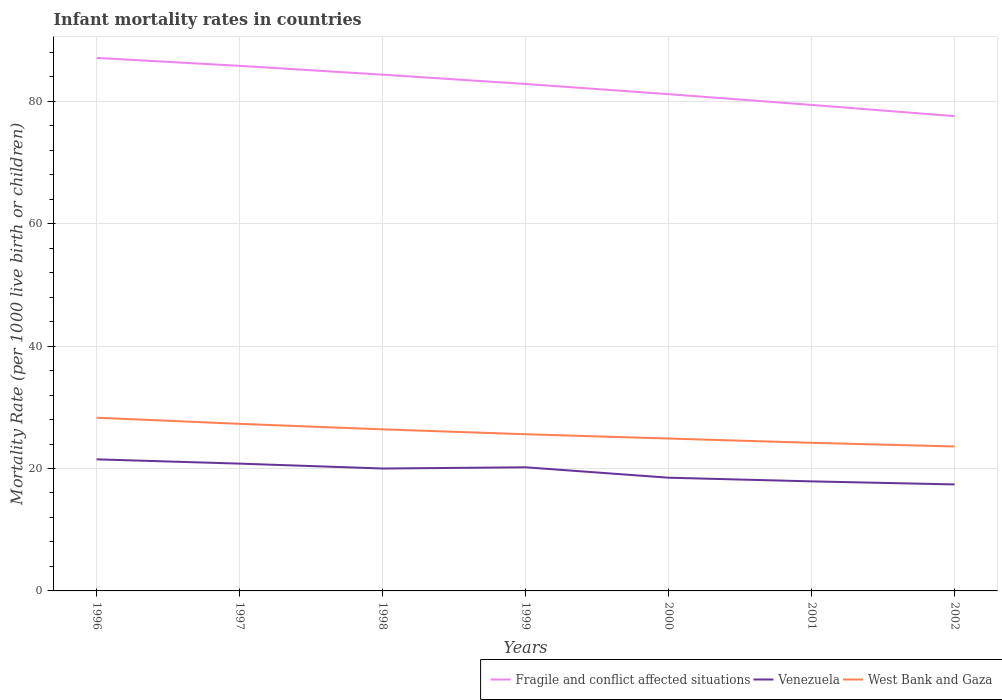Is the number of lines equal to the number of legend labels?
Provide a succinct answer. Yes. Across all years, what is the maximum infant mortality rate in Venezuela?
Keep it short and to the point. 17.4. In which year was the infant mortality rate in Venezuela maximum?
Keep it short and to the point. 2002. What is the total infant mortality rate in Venezuela in the graph?
Offer a terse response. 3.6. What is the difference between the highest and the second highest infant mortality rate in Fragile and conflict affected situations?
Provide a succinct answer. 9.52. Is the infant mortality rate in West Bank and Gaza strictly greater than the infant mortality rate in Venezuela over the years?
Ensure brevity in your answer.  No. What is the difference between two consecutive major ticks on the Y-axis?
Give a very brief answer. 20. Does the graph contain any zero values?
Offer a very short reply. No. Does the graph contain grids?
Your response must be concise. Yes. Where does the legend appear in the graph?
Give a very brief answer. Bottom right. How are the legend labels stacked?
Keep it short and to the point. Horizontal. What is the title of the graph?
Give a very brief answer. Infant mortality rates in countries. What is the label or title of the X-axis?
Offer a very short reply. Years. What is the label or title of the Y-axis?
Give a very brief answer. Mortality Rate (per 1000 live birth or children). What is the Mortality Rate (per 1000 live birth or children) of Fragile and conflict affected situations in 1996?
Ensure brevity in your answer.  87.09. What is the Mortality Rate (per 1000 live birth or children) in West Bank and Gaza in 1996?
Your answer should be very brief. 28.3. What is the Mortality Rate (per 1000 live birth or children) in Fragile and conflict affected situations in 1997?
Provide a succinct answer. 85.79. What is the Mortality Rate (per 1000 live birth or children) in Venezuela in 1997?
Give a very brief answer. 20.8. What is the Mortality Rate (per 1000 live birth or children) in West Bank and Gaza in 1997?
Your answer should be compact. 27.3. What is the Mortality Rate (per 1000 live birth or children) in Fragile and conflict affected situations in 1998?
Ensure brevity in your answer.  84.35. What is the Mortality Rate (per 1000 live birth or children) in West Bank and Gaza in 1998?
Provide a short and direct response. 26.4. What is the Mortality Rate (per 1000 live birth or children) of Fragile and conflict affected situations in 1999?
Give a very brief answer. 82.83. What is the Mortality Rate (per 1000 live birth or children) of Venezuela in 1999?
Make the answer very short. 20.2. What is the Mortality Rate (per 1000 live birth or children) of West Bank and Gaza in 1999?
Provide a succinct answer. 25.6. What is the Mortality Rate (per 1000 live birth or children) of Fragile and conflict affected situations in 2000?
Make the answer very short. 81.17. What is the Mortality Rate (per 1000 live birth or children) in West Bank and Gaza in 2000?
Make the answer very short. 24.9. What is the Mortality Rate (per 1000 live birth or children) of Fragile and conflict affected situations in 2001?
Give a very brief answer. 79.41. What is the Mortality Rate (per 1000 live birth or children) of West Bank and Gaza in 2001?
Make the answer very short. 24.2. What is the Mortality Rate (per 1000 live birth or children) in Fragile and conflict affected situations in 2002?
Offer a terse response. 77.58. What is the Mortality Rate (per 1000 live birth or children) in West Bank and Gaza in 2002?
Give a very brief answer. 23.6. Across all years, what is the maximum Mortality Rate (per 1000 live birth or children) in Fragile and conflict affected situations?
Provide a short and direct response. 87.09. Across all years, what is the maximum Mortality Rate (per 1000 live birth or children) in Venezuela?
Provide a short and direct response. 21.5. Across all years, what is the maximum Mortality Rate (per 1000 live birth or children) in West Bank and Gaza?
Keep it short and to the point. 28.3. Across all years, what is the minimum Mortality Rate (per 1000 live birth or children) of Fragile and conflict affected situations?
Your answer should be compact. 77.58. Across all years, what is the minimum Mortality Rate (per 1000 live birth or children) in Venezuela?
Provide a succinct answer. 17.4. Across all years, what is the minimum Mortality Rate (per 1000 live birth or children) in West Bank and Gaza?
Your answer should be compact. 23.6. What is the total Mortality Rate (per 1000 live birth or children) in Fragile and conflict affected situations in the graph?
Make the answer very short. 578.23. What is the total Mortality Rate (per 1000 live birth or children) of Venezuela in the graph?
Provide a succinct answer. 136.3. What is the total Mortality Rate (per 1000 live birth or children) of West Bank and Gaza in the graph?
Give a very brief answer. 180.3. What is the difference between the Mortality Rate (per 1000 live birth or children) of Fragile and conflict affected situations in 1996 and that in 1997?
Offer a terse response. 1.3. What is the difference between the Mortality Rate (per 1000 live birth or children) of Fragile and conflict affected situations in 1996 and that in 1998?
Make the answer very short. 2.74. What is the difference between the Mortality Rate (per 1000 live birth or children) in Venezuela in 1996 and that in 1998?
Ensure brevity in your answer.  1.5. What is the difference between the Mortality Rate (per 1000 live birth or children) in Fragile and conflict affected situations in 1996 and that in 1999?
Ensure brevity in your answer.  4.26. What is the difference between the Mortality Rate (per 1000 live birth or children) of Fragile and conflict affected situations in 1996 and that in 2000?
Provide a succinct answer. 5.93. What is the difference between the Mortality Rate (per 1000 live birth or children) in Venezuela in 1996 and that in 2000?
Make the answer very short. 3. What is the difference between the Mortality Rate (per 1000 live birth or children) of Fragile and conflict affected situations in 1996 and that in 2001?
Provide a short and direct response. 7.68. What is the difference between the Mortality Rate (per 1000 live birth or children) in Fragile and conflict affected situations in 1996 and that in 2002?
Offer a very short reply. 9.52. What is the difference between the Mortality Rate (per 1000 live birth or children) of Venezuela in 1996 and that in 2002?
Offer a very short reply. 4.1. What is the difference between the Mortality Rate (per 1000 live birth or children) of Fragile and conflict affected situations in 1997 and that in 1998?
Offer a terse response. 1.44. What is the difference between the Mortality Rate (per 1000 live birth or children) of Fragile and conflict affected situations in 1997 and that in 1999?
Your answer should be very brief. 2.96. What is the difference between the Mortality Rate (per 1000 live birth or children) in Venezuela in 1997 and that in 1999?
Your response must be concise. 0.6. What is the difference between the Mortality Rate (per 1000 live birth or children) in Fragile and conflict affected situations in 1997 and that in 2000?
Give a very brief answer. 4.63. What is the difference between the Mortality Rate (per 1000 live birth or children) in Venezuela in 1997 and that in 2000?
Provide a succinct answer. 2.3. What is the difference between the Mortality Rate (per 1000 live birth or children) in Fragile and conflict affected situations in 1997 and that in 2001?
Your answer should be compact. 6.38. What is the difference between the Mortality Rate (per 1000 live birth or children) in Venezuela in 1997 and that in 2001?
Give a very brief answer. 2.9. What is the difference between the Mortality Rate (per 1000 live birth or children) of Fragile and conflict affected situations in 1997 and that in 2002?
Offer a terse response. 8.22. What is the difference between the Mortality Rate (per 1000 live birth or children) of West Bank and Gaza in 1997 and that in 2002?
Offer a terse response. 3.7. What is the difference between the Mortality Rate (per 1000 live birth or children) of Fragile and conflict affected situations in 1998 and that in 1999?
Your answer should be very brief. 1.52. What is the difference between the Mortality Rate (per 1000 live birth or children) of Fragile and conflict affected situations in 1998 and that in 2000?
Offer a terse response. 3.19. What is the difference between the Mortality Rate (per 1000 live birth or children) of Fragile and conflict affected situations in 1998 and that in 2001?
Give a very brief answer. 4.94. What is the difference between the Mortality Rate (per 1000 live birth or children) of West Bank and Gaza in 1998 and that in 2001?
Offer a very short reply. 2.2. What is the difference between the Mortality Rate (per 1000 live birth or children) in Fragile and conflict affected situations in 1998 and that in 2002?
Provide a short and direct response. 6.78. What is the difference between the Mortality Rate (per 1000 live birth or children) of West Bank and Gaza in 1998 and that in 2002?
Provide a succinct answer. 2.8. What is the difference between the Mortality Rate (per 1000 live birth or children) in Fragile and conflict affected situations in 1999 and that in 2000?
Your answer should be compact. 1.67. What is the difference between the Mortality Rate (per 1000 live birth or children) in Venezuela in 1999 and that in 2000?
Ensure brevity in your answer.  1.7. What is the difference between the Mortality Rate (per 1000 live birth or children) in West Bank and Gaza in 1999 and that in 2000?
Make the answer very short. 0.7. What is the difference between the Mortality Rate (per 1000 live birth or children) of Fragile and conflict affected situations in 1999 and that in 2001?
Offer a terse response. 3.42. What is the difference between the Mortality Rate (per 1000 live birth or children) of West Bank and Gaza in 1999 and that in 2001?
Make the answer very short. 1.4. What is the difference between the Mortality Rate (per 1000 live birth or children) of Fragile and conflict affected situations in 1999 and that in 2002?
Your answer should be compact. 5.26. What is the difference between the Mortality Rate (per 1000 live birth or children) in West Bank and Gaza in 1999 and that in 2002?
Keep it short and to the point. 2. What is the difference between the Mortality Rate (per 1000 live birth or children) of Fragile and conflict affected situations in 2000 and that in 2001?
Provide a succinct answer. 1.76. What is the difference between the Mortality Rate (per 1000 live birth or children) in Fragile and conflict affected situations in 2000 and that in 2002?
Offer a terse response. 3.59. What is the difference between the Mortality Rate (per 1000 live birth or children) in Venezuela in 2000 and that in 2002?
Ensure brevity in your answer.  1.1. What is the difference between the Mortality Rate (per 1000 live birth or children) of West Bank and Gaza in 2000 and that in 2002?
Make the answer very short. 1.3. What is the difference between the Mortality Rate (per 1000 live birth or children) in Fragile and conflict affected situations in 2001 and that in 2002?
Ensure brevity in your answer.  1.83. What is the difference between the Mortality Rate (per 1000 live birth or children) in West Bank and Gaza in 2001 and that in 2002?
Make the answer very short. 0.6. What is the difference between the Mortality Rate (per 1000 live birth or children) in Fragile and conflict affected situations in 1996 and the Mortality Rate (per 1000 live birth or children) in Venezuela in 1997?
Give a very brief answer. 66.29. What is the difference between the Mortality Rate (per 1000 live birth or children) of Fragile and conflict affected situations in 1996 and the Mortality Rate (per 1000 live birth or children) of West Bank and Gaza in 1997?
Give a very brief answer. 59.79. What is the difference between the Mortality Rate (per 1000 live birth or children) in Venezuela in 1996 and the Mortality Rate (per 1000 live birth or children) in West Bank and Gaza in 1997?
Your answer should be very brief. -5.8. What is the difference between the Mortality Rate (per 1000 live birth or children) of Fragile and conflict affected situations in 1996 and the Mortality Rate (per 1000 live birth or children) of Venezuela in 1998?
Your answer should be very brief. 67.09. What is the difference between the Mortality Rate (per 1000 live birth or children) of Fragile and conflict affected situations in 1996 and the Mortality Rate (per 1000 live birth or children) of West Bank and Gaza in 1998?
Offer a very short reply. 60.69. What is the difference between the Mortality Rate (per 1000 live birth or children) in Fragile and conflict affected situations in 1996 and the Mortality Rate (per 1000 live birth or children) in Venezuela in 1999?
Your answer should be very brief. 66.89. What is the difference between the Mortality Rate (per 1000 live birth or children) in Fragile and conflict affected situations in 1996 and the Mortality Rate (per 1000 live birth or children) in West Bank and Gaza in 1999?
Give a very brief answer. 61.49. What is the difference between the Mortality Rate (per 1000 live birth or children) in Fragile and conflict affected situations in 1996 and the Mortality Rate (per 1000 live birth or children) in Venezuela in 2000?
Offer a very short reply. 68.59. What is the difference between the Mortality Rate (per 1000 live birth or children) in Fragile and conflict affected situations in 1996 and the Mortality Rate (per 1000 live birth or children) in West Bank and Gaza in 2000?
Your response must be concise. 62.19. What is the difference between the Mortality Rate (per 1000 live birth or children) of Venezuela in 1996 and the Mortality Rate (per 1000 live birth or children) of West Bank and Gaza in 2000?
Provide a short and direct response. -3.4. What is the difference between the Mortality Rate (per 1000 live birth or children) in Fragile and conflict affected situations in 1996 and the Mortality Rate (per 1000 live birth or children) in Venezuela in 2001?
Your response must be concise. 69.19. What is the difference between the Mortality Rate (per 1000 live birth or children) in Fragile and conflict affected situations in 1996 and the Mortality Rate (per 1000 live birth or children) in West Bank and Gaza in 2001?
Your response must be concise. 62.89. What is the difference between the Mortality Rate (per 1000 live birth or children) in Fragile and conflict affected situations in 1996 and the Mortality Rate (per 1000 live birth or children) in Venezuela in 2002?
Your answer should be compact. 69.69. What is the difference between the Mortality Rate (per 1000 live birth or children) in Fragile and conflict affected situations in 1996 and the Mortality Rate (per 1000 live birth or children) in West Bank and Gaza in 2002?
Make the answer very short. 63.49. What is the difference between the Mortality Rate (per 1000 live birth or children) of Venezuela in 1996 and the Mortality Rate (per 1000 live birth or children) of West Bank and Gaza in 2002?
Ensure brevity in your answer.  -2.1. What is the difference between the Mortality Rate (per 1000 live birth or children) of Fragile and conflict affected situations in 1997 and the Mortality Rate (per 1000 live birth or children) of Venezuela in 1998?
Your answer should be compact. 65.79. What is the difference between the Mortality Rate (per 1000 live birth or children) of Fragile and conflict affected situations in 1997 and the Mortality Rate (per 1000 live birth or children) of West Bank and Gaza in 1998?
Your answer should be compact. 59.39. What is the difference between the Mortality Rate (per 1000 live birth or children) in Fragile and conflict affected situations in 1997 and the Mortality Rate (per 1000 live birth or children) in Venezuela in 1999?
Keep it short and to the point. 65.59. What is the difference between the Mortality Rate (per 1000 live birth or children) of Fragile and conflict affected situations in 1997 and the Mortality Rate (per 1000 live birth or children) of West Bank and Gaza in 1999?
Your answer should be compact. 60.19. What is the difference between the Mortality Rate (per 1000 live birth or children) of Venezuela in 1997 and the Mortality Rate (per 1000 live birth or children) of West Bank and Gaza in 1999?
Offer a very short reply. -4.8. What is the difference between the Mortality Rate (per 1000 live birth or children) of Fragile and conflict affected situations in 1997 and the Mortality Rate (per 1000 live birth or children) of Venezuela in 2000?
Your answer should be very brief. 67.29. What is the difference between the Mortality Rate (per 1000 live birth or children) of Fragile and conflict affected situations in 1997 and the Mortality Rate (per 1000 live birth or children) of West Bank and Gaza in 2000?
Offer a terse response. 60.89. What is the difference between the Mortality Rate (per 1000 live birth or children) in Fragile and conflict affected situations in 1997 and the Mortality Rate (per 1000 live birth or children) in Venezuela in 2001?
Provide a short and direct response. 67.89. What is the difference between the Mortality Rate (per 1000 live birth or children) of Fragile and conflict affected situations in 1997 and the Mortality Rate (per 1000 live birth or children) of West Bank and Gaza in 2001?
Your response must be concise. 61.59. What is the difference between the Mortality Rate (per 1000 live birth or children) of Venezuela in 1997 and the Mortality Rate (per 1000 live birth or children) of West Bank and Gaza in 2001?
Provide a succinct answer. -3.4. What is the difference between the Mortality Rate (per 1000 live birth or children) of Fragile and conflict affected situations in 1997 and the Mortality Rate (per 1000 live birth or children) of Venezuela in 2002?
Provide a short and direct response. 68.39. What is the difference between the Mortality Rate (per 1000 live birth or children) in Fragile and conflict affected situations in 1997 and the Mortality Rate (per 1000 live birth or children) in West Bank and Gaza in 2002?
Your answer should be compact. 62.19. What is the difference between the Mortality Rate (per 1000 live birth or children) in Fragile and conflict affected situations in 1998 and the Mortality Rate (per 1000 live birth or children) in Venezuela in 1999?
Your answer should be compact. 64.15. What is the difference between the Mortality Rate (per 1000 live birth or children) of Fragile and conflict affected situations in 1998 and the Mortality Rate (per 1000 live birth or children) of West Bank and Gaza in 1999?
Provide a short and direct response. 58.75. What is the difference between the Mortality Rate (per 1000 live birth or children) in Fragile and conflict affected situations in 1998 and the Mortality Rate (per 1000 live birth or children) in Venezuela in 2000?
Your response must be concise. 65.85. What is the difference between the Mortality Rate (per 1000 live birth or children) of Fragile and conflict affected situations in 1998 and the Mortality Rate (per 1000 live birth or children) of West Bank and Gaza in 2000?
Offer a very short reply. 59.45. What is the difference between the Mortality Rate (per 1000 live birth or children) of Fragile and conflict affected situations in 1998 and the Mortality Rate (per 1000 live birth or children) of Venezuela in 2001?
Provide a short and direct response. 66.45. What is the difference between the Mortality Rate (per 1000 live birth or children) of Fragile and conflict affected situations in 1998 and the Mortality Rate (per 1000 live birth or children) of West Bank and Gaza in 2001?
Ensure brevity in your answer.  60.15. What is the difference between the Mortality Rate (per 1000 live birth or children) in Venezuela in 1998 and the Mortality Rate (per 1000 live birth or children) in West Bank and Gaza in 2001?
Your answer should be very brief. -4.2. What is the difference between the Mortality Rate (per 1000 live birth or children) in Fragile and conflict affected situations in 1998 and the Mortality Rate (per 1000 live birth or children) in Venezuela in 2002?
Give a very brief answer. 66.95. What is the difference between the Mortality Rate (per 1000 live birth or children) in Fragile and conflict affected situations in 1998 and the Mortality Rate (per 1000 live birth or children) in West Bank and Gaza in 2002?
Make the answer very short. 60.75. What is the difference between the Mortality Rate (per 1000 live birth or children) of Venezuela in 1998 and the Mortality Rate (per 1000 live birth or children) of West Bank and Gaza in 2002?
Provide a succinct answer. -3.6. What is the difference between the Mortality Rate (per 1000 live birth or children) in Fragile and conflict affected situations in 1999 and the Mortality Rate (per 1000 live birth or children) in Venezuela in 2000?
Ensure brevity in your answer.  64.33. What is the difference between the Mortality Rate (per 1000 live birth or children) in Fragile and conflict affected situations in 1999 and the Mortality Rate (per 1000 live birth or children) in West Bank and Gaza in 2000?
Offer a very short reply. 57.93. What is the difference between the Mortality Rate (per 1000 live birth or children) in Fragile and conflict affected situations in 1999 and the Mortality Rate (per 1000 live birth or children) in Venezuela in 2001?
Offer a terse response. 64.93. What is the difference between the Mortality Rate (per 1000 live birth or children) of Fragile and conflict affected situations in 1999 and the Mortality Rate (per 1000 live birth or children) of West Bank and Gaza in 2001?
Give a very brief answer. 58.63. What is the difference between the Mortality Rate (per 1000 live birth or children) in Venezuela in 1999 and the Mortality Rate (per 1000 live birth or children) in West Bank and Gaza in 2001?
Your response must be concise. -4. What is the difference between the Mortality Rate (per 1000 live birth or children) of Fragile and conflict affected situations in 1999 and the Mortality Rate (per 1000 live birth or children) of Venezuela in 2002?
Give a very brief answer. 65.43. What is the difference between the Mortality Rate (per 1000 live birth or children) of Fragile and conflict affected situations in 1999 and the Mortality Rate (per 1000 live birth or children) of West Bank and Gaza in 2002?
Make the answer very short. 59.23. What is the difference between the Mortality Rate (per 1000 live birth or children) of Venezuela in 1999 and the Mortality Rate (per 1000 live birth or children) of West Bank and Gaza in 2002?
Your response must be concise. -3.4. What is the difference between the Mortality Rate (per 1000 live birth or children) of Fragile and conflict affected situations in 2000 and the Mortality Rate (per 1000 live birth or children) of Venezuela in 2001?
Keep it short and to the point. 63.27. What is the difference between the Mortality Rate (per 1000 live birth or children) in Fragile and conflict affected situations in 2000 and the Mortality Rate (per 1000 live birth or children) in West Bank and Gaza in 2001?
Keep it short and to the point. 56.97. What is the difference between the Mortality Rate (per 1000 live birth or children) of Venezuela in 2000 and the Mortality Rate (per 1000 live birth or children) of West Bank and Gaza in 2001?
Your answer should be compact. -5.7. What is the difference between the Mortality Rate (per 1000 live birth or children) in Fragile and conflict affected situations in 2000 and the Mortality Rate (per 1000 live birth or children) in Venezuela in 2002?
Offer a very short reply. 63.77. What is the difference between the Mortality Rate (per 1000 live birth or children) in Fragile and conflict affected situations in 2000 and the Mortality Rate (per 1000 live birth or children) in West Bank and Gaza in 2002?
Your response must be concise. 57.57. What is the difference between the Mortality Rate (per 1000 live birth or children) of Venezuela in 2000 and the Mortality Rate (per 1000 live birth or children) of West Bank and Gaza in 2002?
Keep it short and to the point. -5.1. What is the difference between the Mortality Rate (per 1000 live birth or children) of Fragile and conflict affected situations in 2001 and the Mortality Rate (per 1000 live birth or children) of Venezuela in 2002?
Your answer should be compact. 62.01. What is the difference between the Mortality Rate (per 1000 live birth or children) in Fragile and conflict affected situations in 2001 and the Mortality Rate (per 1000 live birth or children) in West Bank and Gaza in 2002?
Provide a short and direct response. 55.81. What is the difference between the Mortality Rate (per 1000 live birth or children) of Venezuela in 2001 and the Mortality Rate (per 1000 live birth or children) of West Bank and Gaza in 2002?
Offer a terse response. -5.7. What is the average Mortality Rate (per 1000 live birth or children) of Fragile and conflict affected situations per year?
Provide a short and direct response. 82.6. What is the average Mortality Rate (per 1000 live birth or children) in Venezuela per year?
Offer a terse response. 19.47. What is the average Mortality Rate (per 1000 live birth or children) of West Bank and Gaza per year?
Offer a very short reply. 25.76. In the year 1996, what is the difference between the Mortality Rate (per 1000 live birth or children) in Fragile and conflict affected situations and Mortality Rate (per 1000 live birth or children) in Venezuela?
Make the answer very short. 65.59. In the year 1996, what is the difference between the Mortality Rate (per 1000 live birth or children) of Fragile and conflict affected situations and Mortality Rate (per 1000 live birth or children) of West Bank and Gaza?
Your answer should be compact. 58.79. In the year 1996, what is the difference between the Mortality Rate (per 1000 live birth or children) of Venezuela and Mortality Rate (per 1000 live birth or children) of West Bank and Gaza?
Offer a terse response. -6.8. In the year 1997, what is the difference between the Mortality Rate (per 1000 live birth or children) in Fragile and conflict affected situations and Mortality Rate (per 1000 live birth or children) in Venezuela?
Your answer should be compact. 64.99. In the year 1997, what is the difference between the Mortality Rate (per 1000 live birth or children) in Fragile and conflict affected situations and Mortality Rate (per 1000 live birth or children) in West Bank and Gaza?
Offer a very short reply. 58.49. In the year 1997, what is the difference between the Mortality Rate (per 1000 live birth or children) in Venezuela and Mortality Rate (per 1000 live birth or children) in West Bank and Gaza?
Offer a terse response. -6.5. In the year 1998, what is the difference between the Mortality Rate (per 1000 live birth or children) of Fragile and conflict affected situations and Mortality Rate (per 1000 live birth or children) of Venezuela?
Ensure brevity in your answer.  64.35. In the year 1998, what is the difference between the Mortality Rate (per 1000 live birth or children) in Fragile and conflict affected situations and Mortality Rate (per 1000 live birth or children) in West Bank and Gaza?
Make the answer very short. 57.95. In the year 1998, what is the difference between the Mortality Rate (per 1000 live birth or children) of Venezuela and Mortality Rate (per 1000 live birth or children) of West Bank and Gaza?
Your answer should be very brief. -6.4. In the year 1999, what is the difference between the Mortality Rate (per 1000 live birth or children) in Fragile and conflict affected situations and Mortality Rate (per 1000 live birth or children) in Venezuela?
Provide a succinct answer. 62.63. In the year 1999, what is the difference between the Mortality Rate (per 1000 live birth or children) in Fragile and conflict affected situations and Mortality Rate (per 1000 live birth or children) in West Bank and Gaza?
Provide a short and direct response. 57.23. In the year 2000, what is the difference between the Mortality Rate (per 1000 live birth or children) in Fragile and conflict affected situations and Mortality Rate (per 1000 live birth or children) in Venezuela?
Offer a very short reply. 62.67. In the year 2000, what is the difference between the Mortality Rate (per 1000 live birth or children) in Fragile and conflict affected situations and Mortality Rate (per 1000 live birth or children) in West Bank and Gaza?
Your answer should be compact. 56.27. In the year 2001, what is the difference between the Mortality Rate (per 1000 live birth or children) of Fragile and conflict affected situations and Mortality Rate (per 1000 live birth or children) of Venezuela?
Offer a terse response. 61.51. In the year 2001, what is the difference between the Mortality Rate (per 1000 live birth or children) in Fragile and conflict affected situations and Mortality Rate (per 1000 live birth or children) in West Bank and Gaza?
Your answer should be compact. 55.21. In the year 2002, what is the difference between the Mortality Rate (per 1000 live birth or children) in Fragile and conflict affected situations and Mortality Rate (per 1000 live birth or children) in Venezuela?
Keep it short and to the point. 60.18. In the year 2002, what is the difference between the Mortality Rate (per 1000 live birth or children) of Fragile and conflict affected situations and Mortality Rate (per 1000 live birth or children) of West Bank and Gaza?
Offer a terse response. 53.98. What is the ratio of the Mortality Rate (per 1000 live birth or children) of Fragile and conflict affected situations in 1996 to that in 1997?
Your answer should be very brief. 1.02. What is the ratio of the Mortality Rate (per 1000 live birth or children) in Venezuela in 1996 to that in 1997?
Offer a terse response. 1.03. What is the ratio of the Mortality Rate (per 1000 live birth or children) of West Bank and Gaza in 1996 to that in 1997?
Ensure brevity in your answer.  1.04. What is the ratio of the Mortality Rate (per 1000 live birth or children) of Fragile and conflict affected situations in 1996 to that in 1998?
Your answer should be compact. 1.03. What is the ratio of the Mortality Rate (per 1000 live birth or children) of Venezuela in 1996 to that in 1998?
Make the answer very short. 1.07. What is the ratio of the Mortality Rate (per 1000 live birth or children) in West Bank and Gaza in 1996 to that in 1998?
Ensure brevity in your answer.  1.07. What is the ratio of the Mortality Rate (per 1000 live birth or children) in Fragile and conflict affected situations in 1996 to that in 1999?
Give a very brief answer. 1.05. What is the ratio of the Mortality Rate (per 1000 live birth or children) in Venezuela in 1996 to that in 1999?
Your answer should be compact. 1.06. What is the ratio of the Mortality Rate (per 1000 live birth or children) in West Bank and Gaza in 1996 to that in 1999?
Your answer should be very brief. 1.11. What is the ratio of the Mortality Rate (per 1000 live birth or children) of Fragile and conflict affected situations in 1996 to that in 2000?
Your answer should be compact. 1.07. What is the ratio of the Mortality Rate (per 1000 live birth or children) of Venezuela in 1996 to that in 2000?
Give a very brief answer. 1.16. What is the ratio of the Mortality Rate (per 1000 live birth or children) in West Bank and Gaza in 1996 to that in 2000?
Your answer should be compact. 1.14. What is the ratio of the Mortality Rate (per 1000 live birth or children) in Fragile and conflict affected situations in 1996 to that in 2001?
Ensure brevity in your answer.  1.1. What is the ratio of the Mortality Rate (per 1000 live birth or children) in Venezuela in 1996 to that in 2001?
Provide a succinct answer. 1.2. What is the ratio of the Mortality Rate (per 1000 live birth or children) in West Bank and Gaza in 1996 to that in 2001?
Keep it short and to the point. 1.17. What is the ratio of the Mortality Rate (per 1000 live birth or children) in Fragile and conflict affected situations in 1996 to that in 2002?
Your answer should be very brief. 1.12. What is the ratio of the Mortality Rate (per 1000 live birth or children) in Venezuela in 1996 to that in 2002?
Provide a short and direct response. 1.24. What is the ratio of the Mortality Rate (per 1000 live birth or children) of West Bank and Gaza in 1996 to that in 2002?
Ensure brevity in your answer.  1.2. What is the ratio of the Mortality Rate (per 1000 live birth or children) in Fragile and conflict affected situations in 1997 to that in 1998?
Offer a terse response. 1.02. What is the ratio of the Mortality Rate (per 1000 live birth or children) in West Bank and Gaza in 1997 to that in 1998?
Your response must be concise. 1.03. What is the ratio of the Mortality Rate (per 1000 live birth or children) in Fragile and conflict affected situations in 1997 to that in 1999?
Provide a succinct answer. 1.04. What is the ratio of the Mortality Rate (per 1000 live birth or children) in Venezuela in 1997 to that in 1999?
Make the answer very short. 1.03. What is the ratio of the Mortality Rate (per 1000 live birth or children) in West Bank and Gaza in 1997 to that in 1999?
Give a very brief answer. 1.07. What is the ratio of the Mortality Rate (per 1000 live birth or children) in Fragile and conflict affected situations in 1997 to that in 2000?
Keep it short and to the point. 1.06. What is the ratio of the Mortality Rate (per 1000 live birth or children) of Venezuela in 1997 to that in 2000?
Your answer should be very brief. 1.12. What is the ratio of the Mortality Rate (per 1000 live birth or children) in West Bank and Gaza in 1997 to that in 2000?
Your answer should be very brief. 1.1. What is the ratio of the Mortality Rate (per 1000 live birth or children) of Fragile and conflict affected situations in 1997 to that in 2001?
Ensure brevity in your answer.  1.08. What is the ratio of the Mortality Rate (per 1000 live birth or children) of Venezuela in 1997 to that in 2001?
Offer a terse response. 1.16. What is the ratio of the Mortality Rate (per 1000 live birth or children) in West Bank and Gaza in 1997 to that in 2001?
Provide a short and direct response. 1.13. What is the ratio of the Mortality Rate (per 1000 live birth or children) in Fragile and conflict affected situations in 1997 to that in 2002?
Provide a short and direct response. 1.11. What is the ratio of the Mortality Rate (per 1000 live birth or children) of Venezuela in 1997 to that in 2002?
Your answer should be very brief. 1.2. What is the ratio of the Mortality Rate (per 1000 live birth or children) in West Bank and Gaza in 1997 to that in 2002?
Provide a succinct answer. 1.16. What is the ratio of the Mortality Rate (per 1000 live birth or children) of Fragile and conflict affected situations in 1998 to that in 1999?
Your response must be concise. 1.02. What is the ratio of the Mortality Rate (per 1000 live birth or children) in Venezuela in 1998 to that in 1999?
Your answer should be compact. 0.99. What is the ratio of the Mortality Rate (per 1000 live birth or children) in West Bank and Gaza in 1998 to that in 1999?
Offer a very short reply. 1.03. What is the ratio of the Mortality Rate (per 1000 live birth or children) of Fragile and conflict affected situations in 1998 to that in 2000?
Ensure brevity in your answer.  1.04. What is the ratio of the Mortality Rate (per 1000 live birth or children) in Venezuela in 1998 to that in 2000?
Your response must be concise. 1.08. What is the ratio of the Mortality Rate (per 1000 live birth or children) in West Bank and Gaza in 1998 to that in 2000?
Your answer should be very brief. 1.06. What is the ratio of the Mortality Rate (per 1000 live birth or children) in Fragile and conflict affected situations in 1998 to that in 2001?
Keep it short and to the point. 1.06. What is the ratio of the Mortality Rate (per 1000 live birth or children) in Venezuela in 1998 to that in 2001?
Give a very brief answer. 1.12. What is the ratio of the Mortality Rate (per 1000 live birth or children) in Fragile and conflict affected situations in 1998 to that in 2002?
Give a very brief answer. 1.09. What is the ratio of the Mortality Rate (per 1000 live birth or children) of Venezuela in 1998 to that in 2002?
Offer a terse response. 1.15. What is the ratio of the Mortality Rate (per 1000 live birth or children) in West Bank and Gaza in 1998 to that in 2002?
Your response must be concise. 1.12. What is the ratio of the Mortality Rate (per 1000 live birth or children) in Fragile and conflict affected situations in 1999 to that in 2000?
Offer a very short reply. 1.02. What is the ratio of the Mortality Rate (per 1000 live birth or children) in Venezuela in 1999 to that in 2000?
Keep it short and to the point. 1.09. What is the ratio of the Mortality Rate (per 1000 live birth or children) in West Bank and Gaza in 1999 to that in 2000?
Keep it short and to the point. 1.03. What is the ratio of the Mortality Rate (per 1000 live birth or children) of Fragile and conflict affected situations in 1999 to that in 2001?
Your answer should be compact. 1.04. What is the ratio of the Mortality Rate (per 1000 live birth or children) of Venezuela in 1999 to that in 2001?
Provide a short and direct response. 1.13. What is the ratio of the Mortality Rate (per 1000 live birth or children) in West Bank and Gaza in 1999 to that in 2001?
Your answer should be compact. 1.06. What is the ratio of the Mortality Rate (per 1000 live birth or children) in Fragile and conflict affected situations in 1999 to that in 2002?
Your answer should be very brief. 1.07. What is the ratio of the Mortality Rate (per 1000 live birth or children) of Venezuela in 1999 to that in 2002?
Ensure brevity in your answer.  1.16. What is the ratio of the Mortality Rate (per 1000 live birth or children) of West Bank and Gaza in 1999 to that in 2002?
Give a very brief answer. 1.08. What is the ratio of the Mortality Rate (per 1000 live birth or children) in Fragile and conflict affected situations in 2000 to that in 2001?
Offer a terse response. 1.02. What is the ratio of the Mortality Rate (per 1000 live birth or children) of Venezuela in 2000 to that in 2001?
Your answer should be very brief. 1.03. What is the ratio of the Mortality Rate (per 1000 live birth or children) in West Bank and Gaza in 2000 to that in 2001?
Your answer should be compact. 1.03. What is the ratio of the Mortality Rate (per 1000 live birth or children) in Fragile and conflict affected situations in 2000 to that in 2002?
Your answer should be very brief. 1.05. What is the ratio of the Mortality Rate (per 1000 live birth or children) in Venezuela in 2000 to that in 2002?
Provide a succinct answer. 1.06. What is the ratio of the Mortality Rate (per 1000 live birth or children) in West Bank and Gaza in 2000 to that in 2002?
Your answer should be compact. 1.06. What is the ratio of the Mortality Rate (per 1000 live birth or children) of Fragile and conflict affected situations in 2001 to that in 2002?
Provide a short and direct response. 1.02. What is the ratio of the Mortality Rate (per 1000 live birth or children) in Venezuela in 2001 to that in 2002?
Provide a succinct answer. 1.03. What is the ratio of the Mortality Rate (per 1000 live birth or children) of West Bank and Gaza in 2001 to that in 2002?
Provide a succinct answer. 1.03. What is the difference between the highest and the second highest Mortality Rate (per 1000 live birth or children) in Fragile and conflict affected situations?
Offer a terse response. 1.3. What is the difference between the highest and the second highest Mortality Rate (per 1000 live birth or children) of West Bank and Gaza?
Ensure brevity in your answer.  1. What is the difference between the highest and the lowest Mortality Rate (per 1000 live birth or children) in Fragile and conflict affected situations?
Your answer should be very brief. 9.52. 